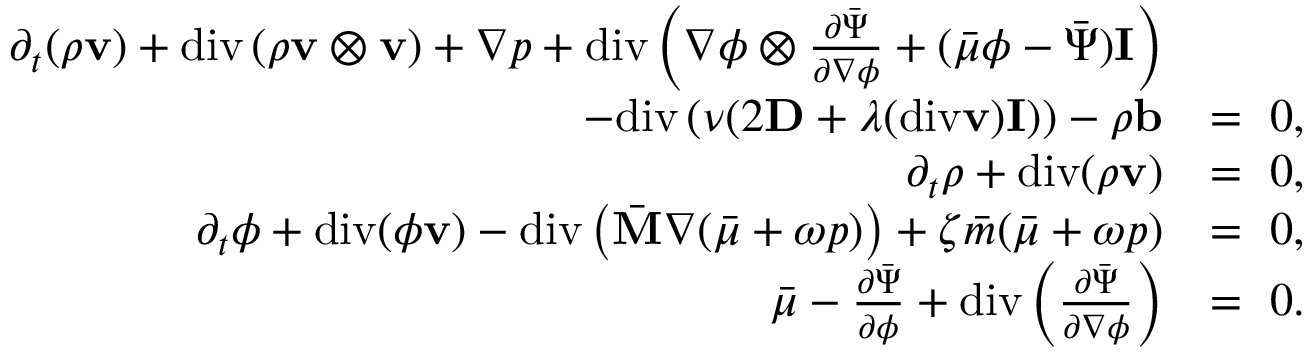Convert formula to latex. <formula><loc_0><loc_0><loc_500><loc_500>\begin{array} { r l } { \partial _ { t } ( \rho v ) + d i v \left ( \rho v \otimes v \right ) + \nabla p + d i v \left ( \nabla \phi \otimes \frac { \partial \bar { \Psi } } { \partial \nabla \phi } + ( \bar { \mu } \phi - \bar { \Psi } ) I \right ) } \\ { - d i v \left ( \nu ( 2 D + \lambda ( d i v v ) I ) \right ) - \rho b } & { = 0 , } \\ { \partial _ { t } \rho + d i v ( \rho v ) } & { = 0 , } \\ { \partial _ { t } \phi + d i v ( \phi v ) - d i v \left ( \bar { M } \nabla ( \bar { \mu } + \omega p ) \right ) + \zeta \bar { m } ( \bar { \mu } + \omega p ) } & { = 0 , } \\ { \bar { \mu } - \frac { \partial \bar { \Psi } } { \partial \phi } + d i v \left ( \frac { \partial \bar { \Psi } } { \partial \nabla \phi } \right ) } & { = 0 . } \end{array}</formula> 